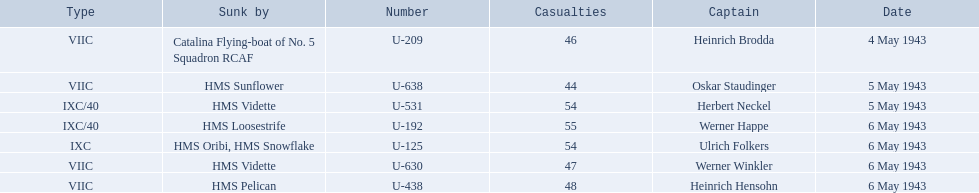Who are the captains of the u boats? Heinrich Brodda, Oskar Staudinger, Herbert Neckel, Werner Happe, Ulrich Folkers, Werner Winkler, Heinrich Hensohn. What are the dates the u boat captains were lost? 4 May 1943, 5 May 1943, 5 May 1943, 6 May 1943, 6 May 1943, 6 May 1943, 6 May 1943. Of these, which were lost on may 5? Oskar Staudinger, Herbert Neckel. Other than oskar staudinger, who else was lost on this day? Herbert Neckel. 